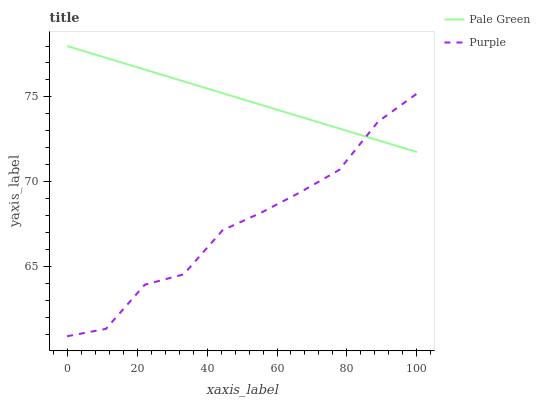Does Purple have the minimum area under the curve?
Answer yes or no. Yes. Does Pale Green have the maximum area under the curve?
Answer yes or no. Yes. Does Pale Green have the minimum area under the curve?
Answer yes or no. No. Is Pale Green the smoothest?
Answer yes or no. Yes. Is Purple the roughest?
Answer yes or no. Yes. Is Pale Green the roughest?
Answer yes or no. No. Does Purple have the lowest value?
Answer yes or no. Yes. Does Pale Green have the lowest value?
Answer yes or no. No. Does Pale Green have the highest value?
Answer yes or no. Yes. Does Pale Green intersect Purple?
Answer yes or no. Yes. Is Pale Green less than Purple?
Answer yes or no. No. Is Pale Green greater than Purple?
Answer yes or no. No. 